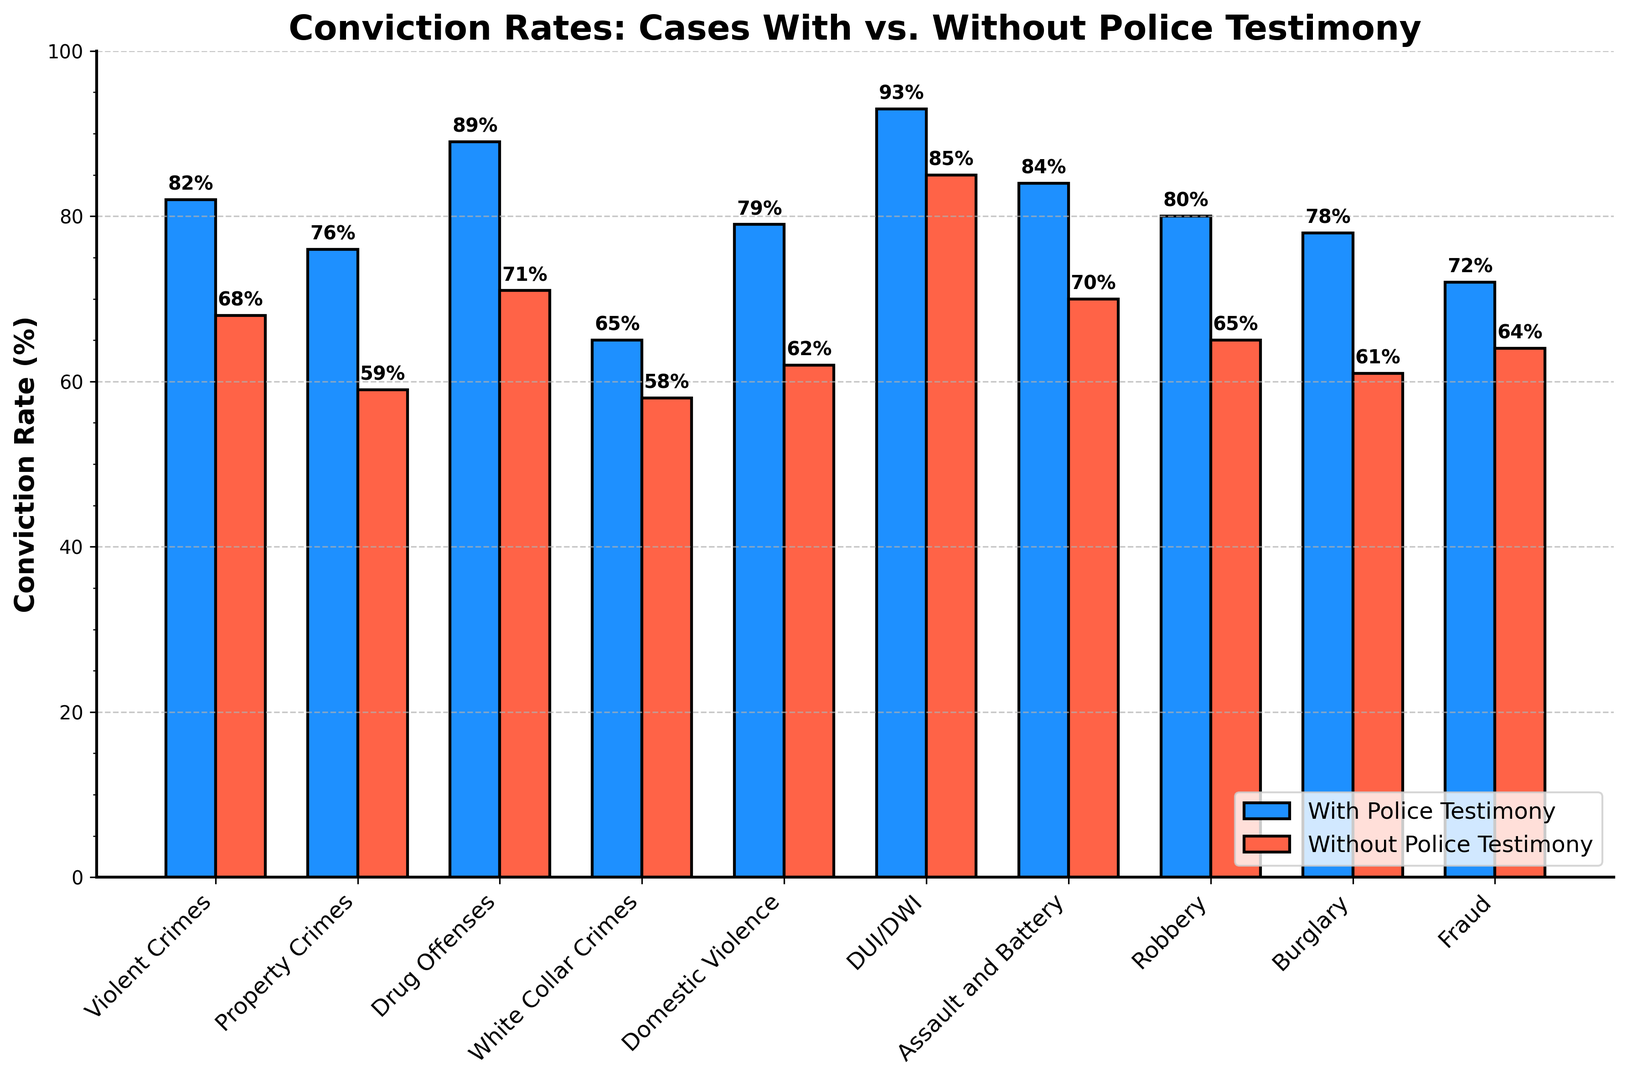Which category has the highest conviction rate without police testimony? Look for the tallest red bar in the 'Without Police Testimony' group. DUI/DWI (93%) is the highest.
Answer: DUI/DWI How much higher is the conviction rate with police testimony for drug offenses compared to without? Find the conviction rates for drug offenses with and without police testimony and calculate the difference: 89% - 71%.
Answer: 18% What is the average conviction rate with police testimony across all categories? Sum all the conviction rates with police testimony and divide by the total number of categories: (82 + 76 + 89 + 65 + 79 + 93 + 84 + 80 + 78 + 72) / 10.
Answer: 79.8% Which category shows the smallest difference in conviction rates between with and without police testimony? Calculate the differences for each category and compare them. Fraud has a difference of 8% (72% - 64%), which is the smallest.
Answer: Fraud Is the conviction rate higher with police testimony or without for domestic violence cases? Compare the heights of blue and red bars for Domestic Violence. The blue bar (79%) is taller.
Answer: With police testimony How much lower is the conviction rate without police testimony for burglary compared to with police testimony? Compute the difference: 78% (with) - 61% (without).
Answer: 17% Which categories have a conviction rate of 80% or more with police testimony? Identify the blue bars with heights at or above 80%. They are Violent Crimes, Drug Offenses, DUI/DWI, Assault and Battery, and Robbery.
Answer: Violent Crimes, Drug Offenses, DUI/DWI, Assault and Battery, Robbery What is the median conviction rate with police testimony? Arrange the conviction rates: [65, 72, 76, 78, 79, 80, 82, 84, 89, 93]. The median is the average of the 5th and 6th values: (79+80)/2.
Answer: 79.5% Which category has the largest drop in conviction rate without police testimony? Calculate the drops and identify the largest. Property Crimes drops from 76% to 59%, a 17% decrease.
Answer: Property Crimes 